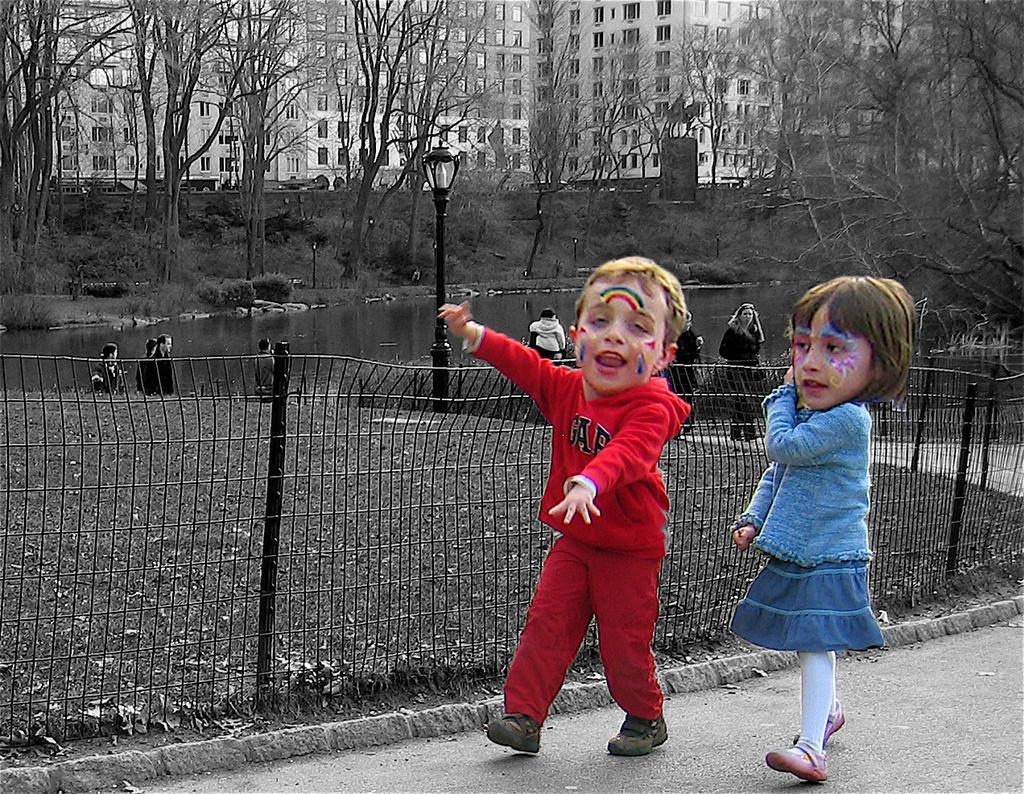How would you summarize this image in a sentence or two? In the picture we can see two children are walking on the path and beside her we can see the fencing and behind it, we can see the grass surface and behind it, we can see some people are standing and we can also see a pole with a lamp and in the background we can see the water surface, areas and the buildings. 